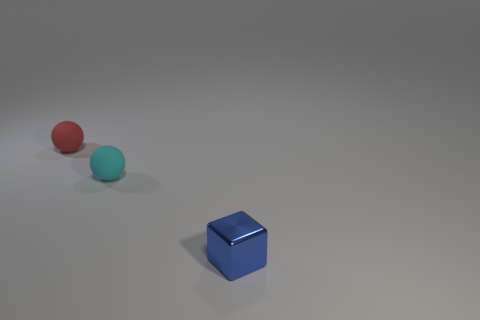Is there a metallic cube of the same size as the cyan ball?
Offer a very short reply. Yes. The small thing that is to the right of the red object and on the left side of the blue shiny thing is made of what material?
Your answer should be very brief. Rubber. How many metallic things are either green cylinders or tiny red balls?
Make the answer very short. 0. There is a cyan object that is the same material as the red sphere; what shape is it?
Your answer should be compact. Sphere. How many small things are on the right side of the small red thing and behind the cube?
Your answer should be very brief. 1. Is there any other thing that is the same shape as the tiny blue object?
Give a very brief answer. No. What number of other things are the same color as the shiny cube?
Make the answer very short. 0. What is the material of the small ball in front of the small rubber thing behind the tiny cyan thing?
Offer a terse response. Rubber. There is a rubber sphere that is to the right of the tiny red rubber sphere; is its color the same as the tiny block?
Offer a terse response. No. Is there anything else that has the same material as the small blue thing?
Your response must be concise. No. 